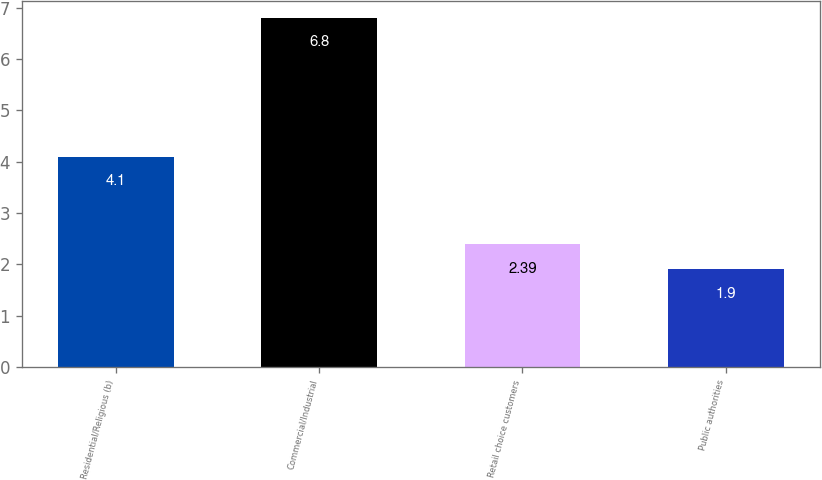Convert chart to OTSL. <chart><loc_0><loc_0><loc_500><loc_500><bar_chart><fcel>Residential/Religious (b)<fcel>Commercial/Industrial<fcel>Retail choice customers<fcel>Public authorities<nl><fcel>4.1<fcel>6.8<fcel>2.39<fcel>1.9<nl></chart> 